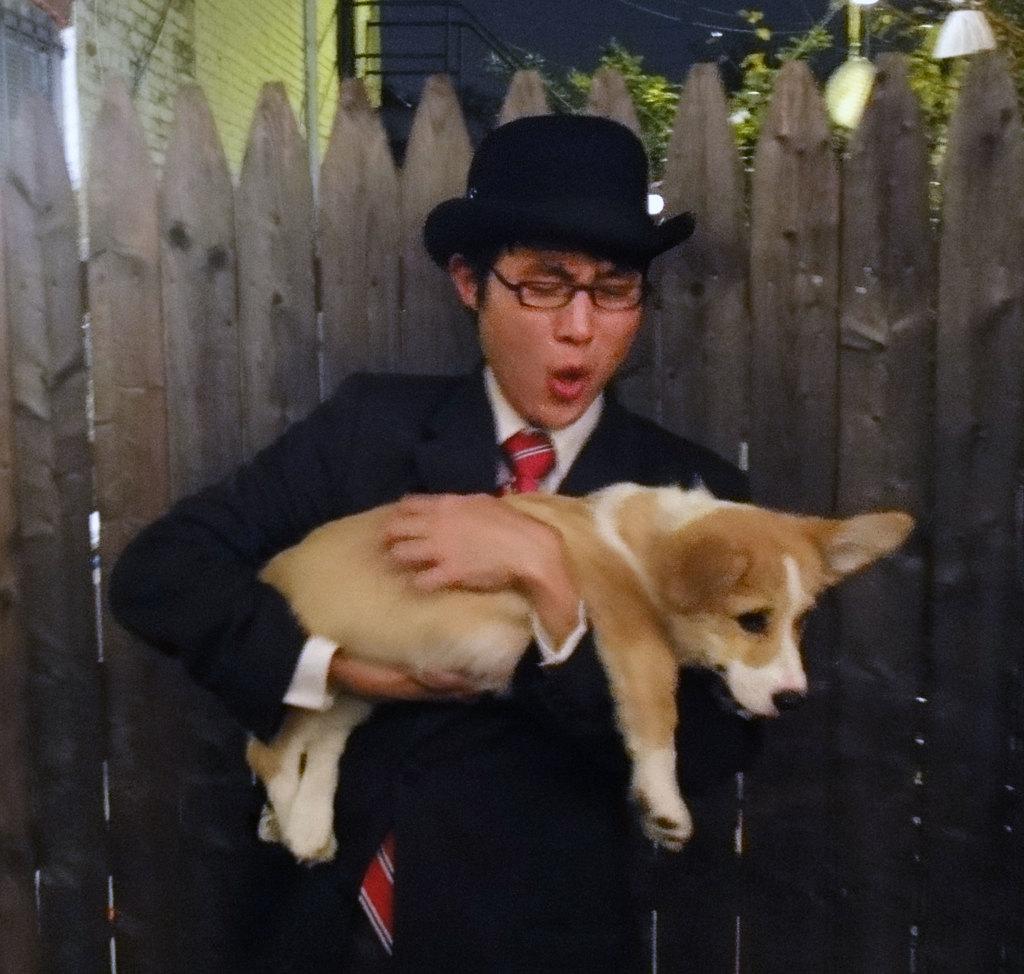In one or two sentences, can you explain what this image depicts? This person standing and holding dog and wear glasses ,hat. On the background we can see trees,wall,wooden fence. 